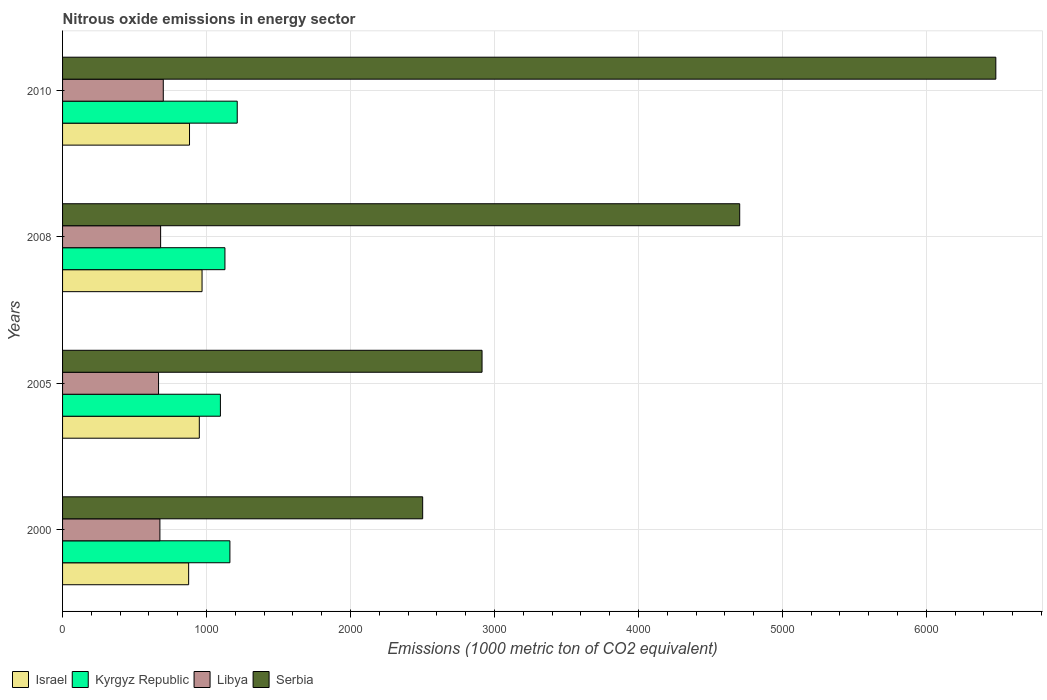Are the number of bars per tick equal to the number of legend labels?
Provide a short and direct response. Yes. Are the number of bars on each tick of the Y-axis equal?
Provide a short and direct response. Yes. How many bars are there on the 1st tick from the bottom?
Provide a succinct answer. 4. What is the label of the 4th group of bars from the top?
Your response must be concise. 2000. In how many cases, is the number of bars for a given year not equal to the number of legend labels?
Offer a very short reply. 0. What is the amount of nitrous oxide emitted in Libya in 2008?
Provide a succinct answer. 681.1. Across all years, what is the maximum amount of nitrous oxide emitted in Kyrgyz Republic?
Provide a short and direct response. 1213.3. Across all years, what is the minimum amount of nitrous oxide emitted in Kyrgyz Republic?
Your response must be concise. 1096.4. In which year was the amount of nitrous oxide emitted in Israel minimum?
Provide a short and direct response. 2000. What is the total amount of nitrous oxide emitted in Libya in the graph?
Provide a succinct answer. 2723.6. What is the difference between the amount of nitrous oxide emitted in Libya in 2000 and that in 2010?
Keep it short and to the point. -23.4. What is the difference between the amount of nitrous oxide emitted in Israel in 2010 and the amount of nitrous oxide emitted in Kyrgyz Republic in 2005?
Give a very brief answer. -214.6. What is the average amount of nitrous oxide emitted in Libya per year?
Provide a succinct answer. 680.9. In the year 2010, what is the difference between the amount of nitrous oxide emitted in Israel and amount of nitrous oxide emitted in Libya?
Provide a succinct answer. 182.2. In how many years, is the amount of nitrous oxide emitted in Israel greater than 3400 1000 metric ton?
Your response must be concise. 0. What is the ratio of the amount of nitrous oxide emitted in Israel in 2000 to that in 2005?
Provide a short and direct response. 0.92. Is the difference between the amount of nitrous oxide emitted in Israel in 2000 and 2010 greater than the difference between the amount of nitrous oxide emitted in Libya in 2000 and 2010?
Ensure brevity in your answer.  Yes. What is the difference between the highest and the second highest amount of nitrous oxide emitted in Israel?
Your answer should be compact. 19. What is the difference between the highest and the lowest amount of nitrous oxide emitted in Serbia?
Provide a short and direct response. 3981.3. Is it the case that in every year, the sum of the amount of nitrous oxide emitted in Israel and amount of nitrous oxide emitted in Libya is greater than the sum of amount of nitrous oxide emitted in Serbia and amount of nitrous oxide emitted in Kyrgyz Republic?
Your response must be concise. Yes. What does the 2nd bar from the bottom in 2010 represents?
Your response must be concise. Kyrgyz Republic. Are all the bars in the graph horizontal?
Your answer should be very brief. Yes. How many years are there in the graph?
Provide a short and direct response. 4. Are the values on the major ticks of X-axis written in scientific E-notation?
Your answer should be compact. No. Where does the legend appear in the graph?
Your answer should be compact. Bottom left. How many legend labels are there?
Provide a short and direct response. 4. How are the legend labels stacked?
Give a very brief answer. Horizontal. What is the title of the graph?
Offer a very short reply. Nitrous oxide emissions in energy sector. What is the label or title of the X-axis?
Your answer should be compact. Emissions (1000 metric ton of CO2 equivalent). What is the label or title of the Y-axis?
Ensure brevity in your answer.  Years. What is the Emissions (1000 metric ton of CO2 equivalent) in Israel in 2000?
Provide a short and direct response. 875.7. What is the Emissions (1000 metric ton of CO2 equivalent) of Kyrgyz Republic in 2000?
Offer a terse response. 1162.4. What is the Emissions (1000 metric ton of CO2 equivalent) in Libya in 2000?
Provide a short and direct response. 676.2. What is the Emissions (1000 metric ton of CO2 equivalent) in Serbia in 2000?
Your answer should be compact. 2501.4. What is the Emissions (1000 metric ton of CO2 equivalent) of Israel in 2005?
Make the answer very short. 949.9. What is the Emissions (1000 metric ton of CO2 equivalent) in Kyrgyz Republic in 2005?
Your response must be concise. 1096.4. What is the Emissions (1000 metric ton of CO2 equivalent) in Libya in 2005?
Your response must be concise. 666.7. What is the Emissions (1000 metric ton of CO2 equivalent) in Serbia in 2005?
Ensure brevity in your answer.  2913.8. What is the Emissions (1000 metric ton of CO2 equivalent) in Israel in 2008?
Keep it short and to the point. 968.9. What is the Emissions (1000 metric ton of CO2 equivalent) of Kyrgyz Republic in 2008?
Your answer should be very brief. 1127.9. What is the Emissions (1000 metric ton of CO2 equivalent) in Libya in 2008?
Provide a short and direct response. 681.1. What is the Emissions (1000 metric ton of CO2 equivalent) of Serbia in 2008?
Your answer should be very brief. 4703.6. What is the Emissions (1000 metric ton of CO2 equivalent) in Israel in 2010?
Offer a very short reply. 881.8. What is the Emissions (1000 metric ton of CO2 equivalent) of Kyrgyz Republic in 2010?
Provide a short and direct response. 1213.3. What is the Emissions (1000 metric ton of CO2 equivalent) in Libya in 2010?
Your response must be concise. 699.6. What is the Emissions (1000 metric ton of CO2 equivalent) of Serbia in 2010?
Offer a terse response. 6482.7. Across all years, what is the maximum Emissions (1000 metric ton of CO2 equivalent) in Israel?
Provide a succinct answer. 968.9. Across all years, what is the maximum Emissions (1000 metric ton of CO2 equivalent) in Kyrgyz Republic?
Give a very brief answer. 1213.3. Across all years, what is the maximum Emissions (1000 metric ton of CO2 equivalent) in Libya?
Your answer should be compact. 699.6. Across all years, what is the maximum Emissions (1000 metric ton of CO2 equivalent) of Serbia?
Give a very brief answer. 6482.7. Across all years, what is the minimum Emissions (1000 metric ton of CO2 equivalent) of Israel?
Provide a succinct answer. 875.7. Across all years, what is the minimum Emissions (1000 metric ton of CO2 equivalent) in Kyrgyz Republic?
Give a very brief answer. 1096.4. Across all years, what is the minimum Emissions (1000 metric ton of CO2 equivalent) in Libya?
Keep it short and to the point. 666.7. Across all years, what is the minimum Emissions (1000 metric ton of CO2 equivalent) in Serbia?
Your answer should be compact. 2501.4. What is the total Emissions (1000 metric ton of CO2 equivalent) of Israel in the graph?
Provide a short and direct response. 3676.3. What is the total Emissions (1000 metric ton of CO2 equivalent) in Kyrgyz Republic in the graph?
Your answer should be compact. 4600. What is the total Emissions (1000 metric ton of CO2 equivalent) of Libya in the graph?
Your response must be concise. 2723.6. What is the total Emissions (1000 metric ton of CO2 equivalent) in Serbia in the graph?
Your answer should be very brief. 1.66e+04. What is the difference between the Emissions (1000 metric ton of CO2 equivalent) in Israel in 2000 and that in 2005?
Keep it short and to the point. -74.2. What is the difference between the Emissions (1000 metric ton of CO2 equivalent) of Libya in 2000 and that in 2005?
Offer a terse response. 9.5. What is the difference between the Emissions (1000 metric ton of CO2 equivalent) of Serbia in 2000 and that in 2005?
Ensure brevity in your answer.  -412.4. What is the difference between the Emissions (1000 metric ton of CO2 equivalent) of Israel in 2000 and that in 2008?
Your answer should be compact. -93.2. What is the difference between the Emissions (1000 metric ton of CO2 equivalent) in Kyrgyz Republic in 2000 and that in 2008?
Give a very brief answer. 34.5. What is the difference between the Emissions (1000 metric ton of CO2 equivalent) in Libya in 2000 and that in 2008?
Offer a very short reply. -4.9. What is the difference between the Emissions (1000 metric ton of CO2 equivalent) in Serbia in 2000 and that in 2008?
Ensure brevity in your answer.  -2202.2. What is the difference between the Emissions (1000 metric ton of CO2 equivalent) in Israel in 2000 and that in 2010?
Give a very brief answer. -6.1. What is the difference between the Emissions (1000 metric ton of CO2 equivalent) in Kyrgyz Republic in 2000 and that in 2010?
Your response must be concise. -50.9. What is the difference between the Emissions (1000 metric ton of CO2 equivalent) of Libya in 2000 and that in 2010?
Provide a short and direct response. -23.4. What is the difference between the Emissions (1000 metric ton of CO2 equivalent) of Serbia in 2000 and that in 2010?
Your answer should be compact. -3981.3. What is the difference between the Emissions (1000 metric ton of CO2 equivalent) of Kyrgyz Republic in 2005 and that in 2008?
Your answer should be very brief. -31.5. What is the difference between the Emissions (1000 metric ton of CO2 equivalent) in Libya in 2005 and that in 2008?
Your response must be concise. -14.4. What is the difference between the Emissions (1000 metric ton of CO2 equivalent) in Serbia in 2005 and that in 2008?
Keep it short and to the point. -1789.8. What is the difference between the Emissions (1000 metric ton of CO2 equivalent) of Israel in 2005 and that in 2010?
Offer a terse response. 68.1. What is the difference between the Emissions (1000 metric ton of CO2 equivalent) of Kyrgyz Republic in 2005 and that in 2010?
Your answer should be very brief. -116.9. What is the difference between the Emissions (1000 metric ton of CO2 equivalent) of Libya in 2005 and that in 2010?
Your answer should be compact. -32.9. What is the difference between the Emissions (1000 metric ton of CO2 equivalent) of Serbia in 2005 and that in 2010?
Offer a very short reply. -3568.9. What is the difference between the Emissions (1000 metric ton of CO2 equivalent) of Israel in 2008 and that in 2010?
Make the answer very short. 87.1. What is the difference between the Emissions (1000 metric ton of CO2 equivalent) of Kyrgyz Republic in 2008 and that in 2010?
Provide a short and direct response. -85.4. What is the difference between the Emissions (1000 metric ton of CO2 equivalent) in Libya in 2008 and that in 2010?
Offer a terse response. -18.5. What is the difference between the Emissions (1000 metric ton of CO2 equivalent) of Serbia in 2008 and that in 2010?
Provide a short and direct response. -1779.1. What is the difference between the Emissions (1000 metric ton of CO2 equivalent) in Israel in 2000 and the Emissions (1000 metric ton of CO2 equivalent) in Kyrgyz Republic in 2005?
Your answer should be compact. -220.7. What is the difference between the Emissions (1000 metric ton of CO2 equivalent) of Israel in 2000 and the Emissions (1000 metric ton of CO2 equivalent) of Libya in 2005?
Offer a terse response. 209. What is the difference between the Emissions (1000 metric ton of CO2 equivalent) in Israel in 2000 and the Emissions (1000 metric ton of CO2 equivalent) in Serbia in 2005?
Keep it short and to the point. -2038.1. What is the difference between the Emissions (1000 metric ton of CO2 equivalent) in Kyrgyz Republic in 2000 and the Emissions (1000 metric ton of CO2 equivalent) in Libya in 2005?
Make the answer very short. 495.7. What is the difference between the Emissions (1000 metric ton of CO2 equivalent) in Kyrgyz Republic in 2000 and the Emissions (1000 metric ton of CO2 equivalent) in Serbia in 2005?
Your response must be concise. -1751.4. What is the difference between the Emissions (1000 metric ton of CO2 equivalent) of Libya in 2000 and the Emissions (1000 metric ton of CO2 equivalent) of Serbia in 2005?
Give a very brief answer. -2237.6. What is the difference between the Emissions (1000 metric ton of CO2 equivalent) of Israel in 2000 and the Emissions (1000 metric ton of CO2 equivalent) of Kyrgyz Republic in 2008?
Offer a very short reply. -252.2. What is the difference between the Emissions (1000 metric ton of CO2 equivalent) in Israel in 2000 and the Emissions (1000 metric ton of CO2 equivalent) in Libya in 2008?
Keep it short and to the point. 194.6. What is the difference between the Emissions (1000 metric ton of CO2 equivalent) in Israel in 2000 and the Emissions (1000 metric ton of CO2 equivalent) in Serbia in 2008?
Your response must be concise. -3827.9. What is the difference between the Emissions (1000 metric ton of CO2 equivalent) in Kyrgyz Republic in 2000 and the Emissions (1000 metric ton of CO2 equivalent) in Libya in 2008?
Make the answer very short. 481.3. What is the difference between the Emissions (1000 metric ton of CO2 equivalent) in Kyrgyz Republic in 2000 and the Emissions (1000 metric ton of CO2 equivalent) in Serbia in 2008?
Your answer should be compact. -3541.2. What is the difference between the Emissions (1000 metric ton of CO2 equivalent) in Libya in 2000 and the Emissions (1000 metric ton of CO2 equivalent) in Serbia in 2008?
Provide a succinct answer. -4027.4. What is the difference between the Emissions (1000 metric ton of CO2 equivalent) of Israel in 2000 and the Emissions (1000 metric ton of CO2 equivalent) of Kyrgyz Republic in 2010?
Offer a terse response. -337.6. What is the difference between the Emissions (1000 metric ton of CO2 equivalent) in Israel in 2000 and the Emissions (1000 metric ton of CO2 equivalent) in Libya in 2010?
Your answer should be very brief. 176.1. What is the difference between the Emissions (1000 metric ton of CO2 equivalent) in Israel in 2000 and the Emissions (1000 metric ton of CO2 equivalent) in Serbia in 2010?
Provide a succinct answer. -5607. What is the difference between the Emissions (1000 metric ton of CO2 equivalent) in Kyrgyz Republic in 2000 and the Emissions (1000 metric ton of CO2 equivalent) in Libya in 2010?
Your response must be concise. 462.8. What is the difference between the Emissions (1000 metric ton of CO2 equivalent) of Kyrgyz Republic in 2000 and the Emissions (1000 metric ton of CO2 equivalent) of Serbia in 2010?
Provide a succinct answer. -5320.3. What is the difference between the Emissions (1000 metric ton of CO2 equivalent) in Libya in 2000 and the Emissions (1000 metric ton of CO2 equivalent) in Serbia in 2010?
Keep it short and to the point. -5806.5. What is the difference between the Emissions (1000 metric ton of CO2 equivalent) of Israel in 2005 and the Emissions (1000 metric ton of CO2 equivalent) of Kyrgyz Republic in 2008?
Your answer should be compact. -178. What is the difference between the Emissions (1000 metric ton of CO2 equivalent) in Israel in 2005 and the Emissions (1000 metric ton of CO2 equivalent) in Libya in 2008?
Your response must be concise. 268.8. What is the difference between the Emissions (1000 metric ton of CO2 equivalent) of Israel in 2005 and the Emissions (1000 metric ton of CO2 equivalent) of Serbia in 2008?
Your response must be concise. -3753.7. What is the difference between the Emissions (1000 metric ton of CO2 equivalent) of Kyrgyz Republic in 2005 and the Emissions (1000 metric ton of CO2 equivalent) of Libya in 2008?
Provide a succinct answer. 415.3. What is the difference between the Emissions (1000 metric ton of CO2 equivalent) in Kyrgyz Republic in 2005 and the Emissions (1000 metric ton of CO2 equivalent) in Serbia in 2008?
Provide a short and direct response. -3607.2. What is the difference between the Emissions (1000 metric ton of CO2 equivalent) in Libya in 2005 and the Emissions (1000 metric ton of CO2 equivalent) in Serbia in 2008?
Your answer should be very brief. -4036.9. What is the difference between the Emissions (1000 metric ton of CO2 equivalent) of Israel in 2005 and the Emissions (1000 metric ton of CO2 equivalent) of Kyrgyz Republic in 2010?
Make the answer very short. -263.4. What is the difference between the Emissions (1000 metric ton of CO2 equivalent) in Israel in 2005 and the Emissions (1000 metric ton of CO2 equivalent) in Libya in 2010?
Offer a terse response. 250.3. What is the difference between the Emissions (1000 metric ton of CO2 equivalent) in Israel in 2005 and the Emissions (1000 metric ton of CO2 equivalent) in Serbia in 2010?
Offer a terse response. -5532.8. What is the difference between the Emissions (1000 metric ton of CO2 equivalent) of Kyrgyz Republic in 2005 and the Emissions (1000 metric ton of CO2 equivalent) of Libya in 2010?
Provide a succinct answer. 396.8. What is the difference between the Emissions (1000 metric ton of CO2 equivalent) of Kyrgyz Republic in 2005 and the Emissions (1000 metric ton of CO2 equivalent) of Serbia in 2010?
Your answer should be compact. -5386.3. What is the difference between the Emissions (1000 metric ton of CO2 equivalent) of Libya in 2005 and the Emissions (1000 metric ton of CO2 equivalent) of Serbia in 2010?
Offer a very short reply. -5816. What is the difference between the Emissions (1000 metric ton of CO2 equivalent) of Israel in 2008 and the Emissions (1000 metric ton of CO2 equivalent) of Kyrgyz Republic in 2010?
Offer a very short reply. -244.4. What is the difference between the Emissions (1000 metric ton of CO2 equivalent) of Israel in 2008 and the Emissions (1000 metric ton of CO2 equivalent) of Libya in 2010?
Offer a terse response. 269.3. What is the difference between the Emissions (1000 metric ton of CO2 equivalent) in Israel in 2008 and the Emissions (1000 metric ton of CO2 equivalent) in Serbia in 2010?
Offer a very short reply. -5513.8. What is the difference between the Emissions (1000 metric ton of CO2 equivalent) in Kyrgyz Republic in 2008 and the Emissions (1000 metric ton of CO2 equivalent) in Libya in 2010?
Provide a short and direct response. 428.3. What is the difference between the Emissions (1000 metric ton of CO2 equivalent) of Kyrgyz Republic in 2008 and the Emissions (1000 metric ton of CO2 equivalent) of Serbia in 2010?
Your response must be concise. -5354.8. What is the difference between the Emissions (1000 metric ton of CO2 equivalent) in Libya in 2008 and the Emissions (1000 metric ton of CO2 equivalent) in Serbia in 2010?
Your answer should be compact. -5801.6. What is the average Emissions (1000 metric ton of CO2 equivalent) in Israel per year?
Offer a terse response. 919.08. What is the average Emissions (1000 metric ton of CO2 equivalent) of Kyrgyz Republic per year?
Your response must be concise. 1150. What is the average Emissions (1000 metric ton of CO2 equivalent) of Libya per year?
Your response must be concise. 680.9. What is the average Emissions (1000 metric ton of CO2 equivalent) in Serbia per year?
Make the answer very short. 4150.38. In the year 2000, what is the difference between the Emissions (1000 metric ton of CO2 equivalent) of Israel and Emissions (1000 metric ton of CO2 equivalent) of Kyrgyz Republic?
Make the answer very short. -286.7. In the year 2000, what is the difference between the Emissions (1000 metric ton of CO2 equivalent) in Israel and Emissions (1000 metric ton of CO2 equivalent) in Libya?
Offer a terse response. 199.5. In the year 2000, what is the difference between the Emissions (1000 metric ton of CO2 equivalent) of Israel and Emissions (1000 metric ton of CO2 equivalent) of Serbia?
Offer a very short reply. -1625.7. In the year 2000, what is the difference between the Emissions (1000 metric ton of CO2 equivalent) in Kyrgyz Republic and Emissions (1000 metric ton of CO2 equivalent) in Libya?
Give a very brief answer. 486.2. In the year 2000, what is the difference between the Emissions (1000 metric ton of CO2 equivalent) of Kyrgyz Republic and Emissions (1000 metric ton of CO2 equivalent) of Serbia?
Your response must be concise. -1339. In the year 2000, what is the difference between the Emissions (1000 metric ton of CO2 equivalent) of Libya and Emissions (1000 metric ton of CO2 equivalent) of Serbia?
Make the answer very short. -1825.2. In the year 2005, what is the difference between the Emissions (1000 metric ton of CO2 equivalent) of Israel and Emissions (1000 metric ton of CO2 equivalent) of Kyrgyz Republic?
Ensure brevity in your answer.  -146.5. In the year 2005, what is the difference between the Emissions (1000 metric ton of CO2 equivalent) in Israel and Emissions (1000 metric ton of CO2 equivalent) in Libya?
Your response must be concise. 283.2. In the year 2005, what is the difference between the Emissions (1000 metric ton of CO2 equivalent) in Israel and Emissions (1000 metric ton of CO2 equivalent) in Serbia?
Keep it short and to the point. -1963.9. In the year 2005, what is the difference between the Emissions (1000 metric ton of CO2 equivalent) of Kyrgyz Republic and Emissions (1000 metric ton of CO2 equivalent) of Libya?
Your answer should be very brief. 429.7. In the year 2005, what is the difference between the Emissions (1000 metric ton of CO2 equivalent) of Kyrgyz Republic and Emissions (1000 metric ton of CO2 equivalent) of Serbia?
Your answer should be very brief. -1817.4. In the year 2005, what is the difference between the Emissions (1000 metric ton of CO2 equivalent) in Libya and Emissions (1000 metric ton of CO2 equivalent) in Serbia?
Your response must be concise. -2247.1. In the year 2008, what is the difference between the Emissions (1000 metric ton of CO2 equivalent) of Israel and Emissions (1000 metric ton of CO2 equivalent) of Kyrgyz Republic?
Your response must be concise. -159. In the year 2008, what is the difference between the Emissions (1000 metric ton of CO2 equivalent) in Israel and Emissions (1000 metric ton of CO2 equivalent) in Libya?
Your answer should be compact. 287.8. In the year 2008, what is the difference between the Emissions (1000 metric ton of CO2 equivalent) in Israel and Emissions (1000 metric ton of CO2 equivalent) in Serbia?
Provide a succinct answer. -3734.7. In the year 2008, what is the difference between the Emissions (1000 metric ton of CO2 equivalent) in Kyrgyz Republic and Emissions (1000 metric ton of CO2 equivalent) in Libya?
Ensure brevity in your answer.  446.8. In the year 2008, what is the difference between the Emissions (1000 metric ton of CO2 equivalent) in Kyrgyz Republic and Emissions (1000 metric ton of CO2 equivalent) in Serbia?
Your answer should be very brief. -3575.7. In the year 2008, what is the difference between the Emissions (1000 metric ton of CO2 equivalent) in Libya and Emissions (1000 metric ton of CO2 equivalent) in Serbia?
Make the answer very short. -4022.5. In the year 2010, what is the difference between the Emissions (1000 metric ton of CO2 equivalent) in Israel and Emissions (1000 metric ton of CO2 equivalent) in Kyrgyz Republic?
Your answer should be compact. -331.5. In the year 2010, what is the difference between the Emissions (1000 metric ton of CO2 equivalent) of Israel and Emissions (1000 metric ton of CO2 equivalent) of Libya?
Your response must be concise. 182.2. In the year 2010, what is the difference between the Emissions (1000 metric ton of CO2 equivalent) of Israel and Emissions (1000 metric ton of CO2 equivalent) of Serbia?
Keep it short and to the point. -5600.9. In the year 2010, what is the difference between the Emissions (1000 metric ton of CO2 equivalent) in Kyrgyz Republic and Emissions (1000 metric ton of CO2 equivalent) in Libya?
Keep it short and to the point. 513.7. In the year 2010, what is the difference between the Emissions (1000 metric ton of CO2 equivalent) of Kyrgyz Republic and Emissions (1000 metric ton of CO2 equivalent) of Serbia?
Provide a short and direct response. -5269.4. In the year 2010, what is the difference between the Emissions (1000 metric ton of CO2 equivalent) in Libya and Emissions (1000 metric ton of CO2 equivalent) in Serbia?
Your answer should be very brief. -5783.1. What is the ratio of the Emissions (1000 metric ton of CO2 equivalent) of Israel in 2000 to that in 2005?
Your answer should be compact. 0.92. What is the ratio of the Emissions (1000 metric ton of CO2 equivalent) of Kyrgyz Republic in 2000 to that in 2005?
Offer a terse response. 1.06. What is the ratio of the Emissions (1000 metric ton of CO2 equivalent) of Libya in 2000 to that in 2005?
Give a very brief answer. 1.01. What is the ratio of the Emissions (1000 metric ton of CO2 equivalent) of Serbia in 2000 to that in 2005?
Your answer should be compact. 0.86. What is the ratio of the Emissions (1000 metric ton of CO2 equivalent) of Israel in 2000 to that in 2008?
Keep it short and to the point. 0.9. What is the ratio of the Emissions (1000 metric ton of CO2 equivalent) of Kyrgyz Republic in 2000 to that in 2008?
Your answer should be very brief. 1.03. What is the ratio of the Emissions (1000 metric ton of CO2 equivalent) of Libya in 2000 to that in 2008?
Offer a terse response. 0.99. What is the ratio of the Emissions (1000 metric ton of CO2 equivalent) of Serbia in 2000 to that in 2008?
Your answer should be very brief. 0.53. What is the ratio of the Emissions (1000 metric ton of CO2 equivalent) in Israel in 2000 to that in 2010?
Give a very brief answer. 0.99. What is the ratio of the Emissions (1000 metric ton of CO2 equivalent) of Kyrgyz Republic in 2000 to that in 2010?
Make the answer very short. 0.96. What is the ratio of the Emissions (1000 metric ton of CO2 equivalent) in Libya in 2000 to that in 2010?
Make the answer very short. 0.97. What is the ratio of the Emissions (1000 metric ton of CO2 equivalent) in Serbia in 2000 to that in 2010?
Ensure brevity in your answer.  0.39. What is the ratio of the Emissions (1000 metric ton of CO2 equivalent) in Israel in 2005 to that in 2008?
Keep it short and to the point. 0.98. What is the ratio of the Emissions (1000 metric ton of CO2 equivalent) in Kyrgyz Republic in 2005 to that in 2008?
Keep it short and to the point. 0.97. What is the ratio of the Emissions (1000 metric ton of CO2 equivalent) of Libya in 2005 to that in 2008?
Provide a short and direct response. 0.98. What is the ratio of the Emissions (1000 metric ton of CO2 equivalent) of Serbia in 2005 to that in 2008?
Give a very brief answer. 0.62. What is the ratio of the Emissions (1000 metric ton of CO2 equivalent) in Israel in 2005 to that in 2010?
Your response must be concise. 1.08. What is the ratio of the Emissions (1000 metric ton of CO2 equivalent) in Kyrgyz Republic in 2005 to that in 2010?
Keep it short and to the point. 0.9. What is the ratio of the Emissions (1000 metric ton of CO2 equivalent) in Libya in 2005 to that in 2010?
Your answer should be very brief. 0.95. What is the ratio of the Emissions (1000 metric ton of CO2 equivalent) of Serbia in 2005 to that in 2010?
Offer a terse response. 0.45. What is the ratio of the Emissions (1000 metric ton of CO2 equivalent) in Israel in 2008 to that in 2010?
Make the answer very short. 1.1. What is the ratio of the Emissions (1000 metric ton of CO2 equivalent) of Kyrgyz Republic in 2008 to that in 2010?
Your answer should be very brief. 0.93. What is the ratio of the Emissions (1000 metric ton of CO2 equivalent) of Libya in 2008 to that in 2010?
Keep it short and to the point. 0.97. What is the ratio of the Emissions (1000 metric ton of CO2 equivalent) of Serbia in 2008 to that in 2010?
Offer a very short reply. 0.73. What is the difference between the highest and the second highest Emissions (1000 metric ton of CO2 equivalent) of Israel?
Your answer should be very brief. 19. What is the difference between the highest and the second highest Emissions (1000 metric ton of CO2 equivalent) of Kyrgyz Republic?
Ensure brevity in your answer.  50.9. What is the difference between the highest and the second highest Emissions (1000 metric ton of CO2 equivalent) of Serbia?
Your response must be concise. 1779.1. What is the difference between the highest and the lowest Emissions (1000 metric ton of CO2 equivalent) in Israel?
Offer a terse response. 93.2. What is the difference between the highest and the lowest Emissions (1000 metric ton of CO2 equivalent) of Kyrgyz Republic?
Offer a terse response. 116.9. What is the difference between the highest and the lowest Emissions (1000 metric ton of CO2 equivalent) in Libya?
Make the answer very short. 32.9. What is the difference between the highest and the lowest Emissions (1000 metric ton of CO2 equivalent) in Serbia?
Make the answer very short. 3981.3. 